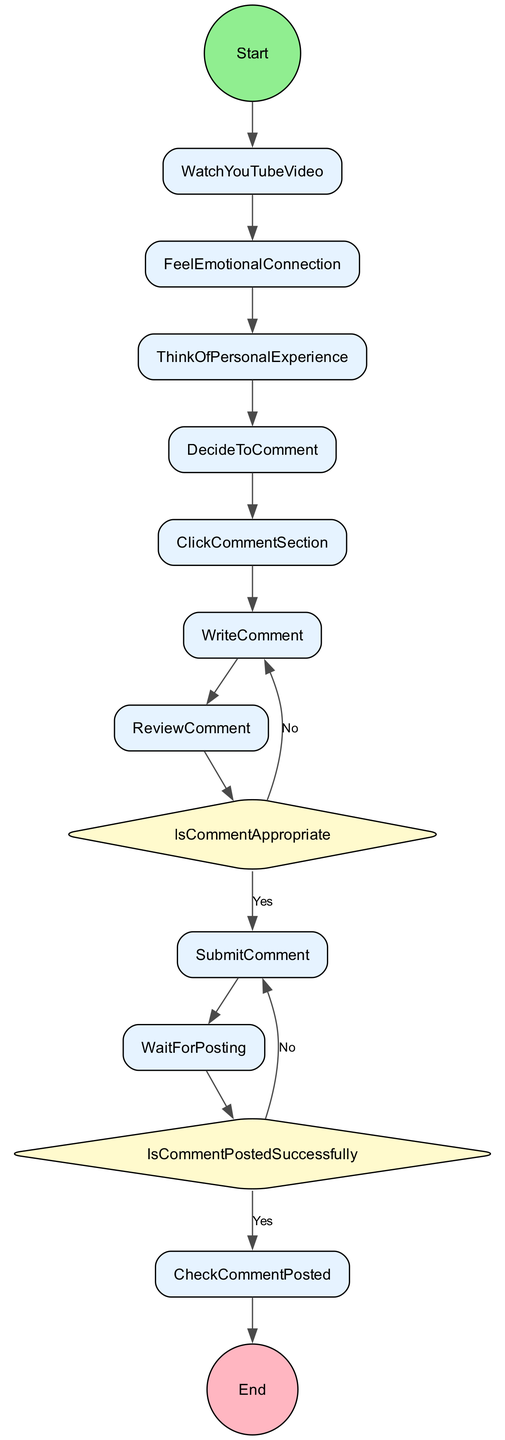What is the start event of the diagram? The start event in the diagram is labeled as "VideoLoading," which indicates the initiation of the activity sequence.
Answer: VideoLoading How many activities are listed in the diagram? The diagram lists a total of ten activities that represent the steps taken when creating and posting a comment.
Answer: 10 What is the first activity after watching a YouTube video? After watching a YouTube video, the next activity is "FeelEmotionalConnection," which signifies an emotional response to the video content.
Answer: FeelEmotionalConnection What happens if the comment is not appropriate? If the comment is not appropriate, the flow returns to the "WriteComment" activity, indicating that the user needs to revise their comment.
Answer: WriteComment What is the final event that signifies the completion of the process? The final event that signifies the completion of the process is labeled as "CommentPosted," marking that the comment has been successfully posted in the comment section.
Answer: CommentPosted What is the decision point regarding the comment's status after submission? The decision point regarding the comment's status after submission is labeled "IsCommentPostedSuccessfully," which evaluates whether the comment was successfully posted or not.
Answer: IsCommentPostedSuccessfully What is the second activity that follows deciding to comment? The second activity that follows the decision to comment is "ClickCommentSection," which shows the action of assessing the comment section before writing.
Answer: ClickCommentSection What is the condition checked after reviewing the comment? After reviewing the comment, the condition checked is "IsCommentAppropriate," which determines whether the comment meets the guidelines for submission.
Answer: IsCommentAppropriate 